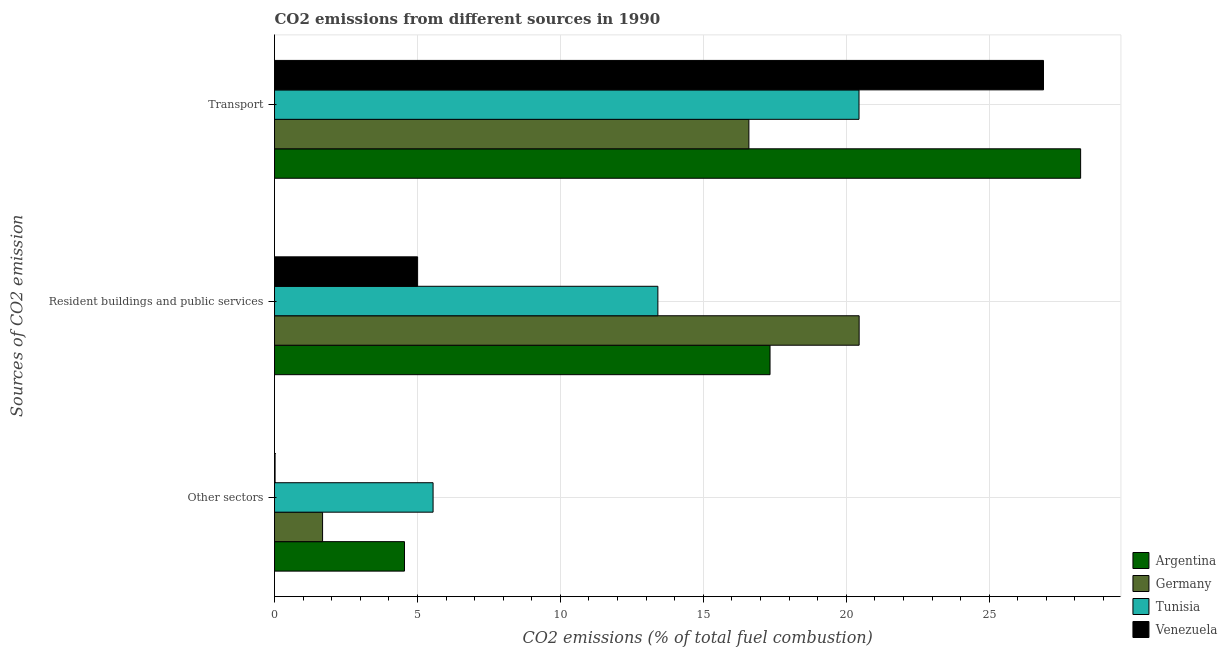How many different coloured bars are there?
Your answer should be very brief. 4. Are the number of bars on each tick of the Y-axis equal?
Make the answer very short. Yes. How many bars are there on the 2nd tick from the top?
Your answer should be compact. 4. How many bars are there on the 3rd tick from the bottom?
Provide a succinct answer. 4. What is the label of the 2nd group of bars from the top?
Give a very brief answer. Resident buildings and public services. What is the percentage of co2 emissions from other sectors in Germany?
Offer a very short reply. 1.68. Across all countries, what is the maximum percentage of co2 emissions from transport?
Keep it short and to the point. 28.2. Across all countries, what is the minimum percentage of co2 emissions from resident buildings and public services?
Your answer should be compact. 5.01. In which country was the percentage of co2 emissions from transport maximum?
Give a very brief answer. Argentina. In which country was the percentage of co2 emissions from other sectors minimum?
Offer a terse response. Venezuela. What is the total percentage of co2 emissions from transport in the graph?
Provide a short and direct response. 92.14. What is the difference between the percentage of co2 emissions from transport in Tunisia and that in Venezuela?
Make the answer very short. -6.45. What is the difference between the percentage of co2 emissions from other sectors in Venezuela and the percentage of co2 emissions from transport in Argentina?
Provide a succinct answer. -28.18. What is the average percentage of co2 emissions from resident buildings and public services per country?
Offer a very short reply. 14.05. What is the difference between the percentage of co2 emissions from transport and percentage of co2 emissions from other sectors in Venezuela?
Offer a very short reply. 26.88. In how many countries, is the percentage of co2 emissions from other sectors greater than 22 %?
Provide a succinct answer. 0. What is the ratio of the percentage of co2 emissions from resident buildings and public services in Germany to that in Venezuela?
Offer a terse response. 4.09. Is the percentage of co2 emissions from transport in Germany less than that in Argentina?
Offer a very short reply. Yes. Is the difference between the percentage of co2 emissions from transport in Tunisia and Germany greater than the difference between the percentage of co2 emissions from resident buildings and public services in Tunisia and Germany?
Keep it short and to the point. Yes. What is the difference between the highest and the second highest percentage of co2 emissions from other sectors?
Provide a succinct answer. 1. What is the difference between the highest and the lowest percentage of co2 emissions from other sectors?
Your answer should be compact. 5.53. In how many countries, is the percentage of co2 emissions from resident buildings and public services greater than the average percentage of co2 emissions from resident buildings and public services taken over all countries?
Make the answer very short. 2. What does the 3rd bar from the top in Transport represents?
Keep it short and to the point. Germany. What does the 3rd bar from the bottom in Other sectors represents?
Your answer should be compact. Tunisia. How are the legend labels stacked?
Offer a very short reply. Vertical. What is the title of the graph?
Offer a terse response. CO2 emissions from different sources in 1990. Does "Guam" appear as one of the legend labels in the graph?
Provide a succinct answer. No. What is the label or title of the X-axis?
Provide a short and direct response. CO2 emissions (% of total fuel combustion). What is the label or title of the Y-axis?
Offer a terse response. Sources of CO2 emission. What is the CO2 emissions (% of total fuel combustion) in Argentina in Other sectors?
Offer a very short reply. 4.55. What is the CO2 emissions (% of total fuel combustion) in Germany in Other sectors?
Provide a succinct answer. 1.68. What is the CO2 emissions (% of total fuel combustion) in Tunisia in Other sectors?
Offer a terse response. 5.55. What is the CO2 emissions (% of total fuel combustion) of Venezuela in Other sectors?
Give a very brief answer. 0.02. What is the CO2 emissions (% of total fuel combustion) of Argentina in Resident buildings and public services?
Make the answer very short. 17.33. What is the CO2 emissions (% of total fuel combustion) in Germany in Resident buildings and public services?
Ensure brevity in your answer.  20.45. What is the CO2 emissions (% of total fuel combustion) in Tunisia in Resident buildings and public services?
Offer a very short reply. 13.41. What is the CO2 emissions (% of total fuel combustion) of Venezuela in Resident buildings and public services?
Your response must be concise. 5.01. What is the CO2 emissions (% of total fuel combustion) in Argentina in Transport?
Offer a terse response. 28.2. What is the CO2 emissions (% of total fuel combustion) of Germany in Transport?
Your answer should be compact. 16.59. What is the CO2 emissions (% of total fuel combustion) in Tunisia in Transport?
Provide a succinct answer. 20.45. What is the CO2 emissions (% of total fuel combustion) of Venezuela in Transport?
Ensure brevity in your answer.  26.9. Across all Sources of CO2 emission, what is the maximum CO2 emissions (% of total fuel combustion) in Argentina?
Provide a short and direct response. 28.2. Across all Sources of CO2 emission, what is the maximum CO2 emissions (% of total fuel combustion) in Germany?
Provide a succinct answer. 20.45. Across all Sources of CO2 emission, what is the maximum CO2 emissions (% of total fuel combustion) in Tunisia?
Your answer should be compact. 20.45. Across all Sources of CO2 emission, what is the maximum CO2 emissions (% of total fuel combustion) in Venezuela?
Your answer should be compact. 26.9. Across all Sources of CO2 emission, what is the minimum CO2 emissions (% of total fuel combustion) of Argentina?
Keep it short and to the point. 4.55. Across all Sources of CO2 emission, what is the minimum CO2 emissions (% of total fuel combustion) of Germany?
Offer a terse response. 1.68. Across all Sources of CO2 emission, what is the minimum CO2 emissions (% of total fuel combustion) of Tunisia?
Make the answer very short. 5.55. Across all Sources of CO2 emission, what is the minimum CO2 emissions (% of total fuel combustion) of Venezuela?
Provide a short and direct response. 0.02. What is the total CO2 emissions (% of total fuel combustion) of Argentina in the graph?
Offer a terse response. 50.08. What is the total CO2 emissions (% of total fuel combustion) of Germany in the graph?
Keep it short and to the point. 38.73. What is the total CO2 emissions (% of total fuel combustion) in Tunisia in the graph?
Your answer should be very brief. 39.4. What is the total CO2 emissions (% of total fuel combustion) of Venezuela in the graph?
Your answer should be very brief. 31.93. What is the difference between the CO2 emissions (% of total fuel combustion) in Argentina in Other sectors and that in Resident buildings and public services?
Ensure brevity in your answer.  -12.79. What is the difference between the CO2 emissions (% of total fuel combustion) of Germany in Other sectors and that in Resident buildings and public services?
Give a very brief answer. -18.77. What is the difference between the CO2 emissions (% of total fuel combustion) of Tunisia in Other sectors and that in Resident buildings and public services?
Provide a succinct answer. -7.86. What is the difference between the CO2 emissions (% of total fuel combustion) in Venezuela in Other sectors and that in Resident buildings and public services?
Your response must be concise. -4.99. What is the difference between the CO2 emissions (% of total fuel combustion) of Argentina in Other sectors and that in Transport?
Make the answer very short. -23.65. What is the difference between the CO2 emissions (% of total fuel combustion) of Germany in Other sectors and that in Transport?
Your response must be concise. -14.91. What is the difference between the CO2 emissions (% of total fuel combustion) of Tunisia in Other sectors and that in Transport?
Your response must be concise. -14.9. What is the difference between the CO2 emissions (% of total fuel combustion) in Venezuela in Other sectors and that in Transport?
Keep it short and to the point. -26.88. What is the difference between the CO2 emissions (% of total fuel combustion) in Argentina in Resident buildings and public services and that in Transport?
Provide a succinct answer. -10.87. What is the difference between the CO2 emissions (% of total fuel combustion) of Germany in Resident buildings and public services and that in Transport?
Give a very brief answer. 3.86. What is the difference between the CO2 emissions (% of total fuel combustion) in Tunisia in Resident buildings and public services and that in Transport?
Offer a terse response. -7.04. What is the difference between the CO2 emissions (% of total fuel combustion) of Venezuela in Resident buildings and public services and that in Transport?
Offer a very short reply. -21.9. What is the difference between the CO2 emissions (% of total fuel combustion) of Argentina in Other sectors and the CO2 emissions (% of total fuel combustion) of Germany in Resident buildings and public services?
Offer a very short reply. -15.91. What is the difference between the CO2 emissions (% of total fuel combustion) in Argentina in Other sectors and the CO2 emissions (% of total fuel combustion) in Tunisia in Resident buildings and public services?
Your answer should be very brief. -8.86. What is the difference between the CO2 emissions (% of total fuel combustion) of Argentina in Other sectors and the CO2 emissions (% of total fuel combustion) of Venezuela in Resident buildings and public services?
Provide a short and direct response. -0.46. What is the difference between the CO2 emissions (% of total fuel combustion) in Germany in Other sectors and the CO2 emissions (% of total fuel combustion) in Tunisia in Resident buildings and public services?
Provide a succinct answer. -11.73. What is the difference between the CO2 emissions (% of total fuel combustion) in Germany in Other sectors and the CO2 emissions (% of total fuel combustion) in Venezuela in Resident buildings and public services?
Give a very brief answer. -3.32. What is the difference between the CO2 emissions (% of total fuel combustion) of Tunisia in Other sectors and the CO2 emissions (% of total fuel combustion) of Venezuela in Resident buildings and public services?
Your answer should be very brief. 0.54. What is the difference between the CO2 emissions (% of total fuel combustion) in Argentina in Other sectors and the CO2 emissions (% of total fuel combustion) in Germany in Transport?
Your answer should be very brief. -12.05. What is the difference between the CO2 emissions (% of total fuel combustion) in Argentina in Other sectors and the CO2 emissions (% of total fuel combustion) in Tunisia in Transport?
Provide a succinct answer. -15.9. What is the difference between the CO2 emissions (% of total fuel combustion) in Argentina in Other sectors and the CO2 emissions (% of total fuel combustion) in Venezuela in Transport?
Your answer should be compact. -22.35. What is the difference between the CO2 emissions (% of total fuel combustion) in Germany in Other sectors and the CO2 emissions (% of total fuel combustion) in Tunisia in Transport?
Give a very brief answer. -18.77. What is the difference between the CO2 emissions (% of total fuel combustion) in Germany in Other sectors and the CO2 emissions (% of total fuel combustion) in Venezuela in Transport?
Ensure brevity in your answer.  -25.22. What is the difference between the CO2 emissions (% of total fuel combustion) of Tunisia in Other sectors and the CO2 emissions (% of total fuel combustion) of Venezuela in Transport?
Ensure brevity in your answer.  -21.35. What is the difference between the CO2 emissions (% of total fuel combustion) of Argentina in Resident buildings and public services and the CO2 emissions (% of total fuel combustion) of Germany in Transport?
Your response must be concise. 0.74. What is the difference between the CO2 emissions (% of total fuel combustion) of Argentina in Resident buildings and public services and the CO2 emissions (% of total fuel combustion) of Tunisia in Transport?
Make the answer very short. -3.11. What is the difference between the CO2 emissions (% of total fuel combustion) of Argentina in Resident buildings and public services and the CO2 emissions (% of total fuel combustion) of Venezuela in Transport?
Your answer should be compact. -9.57. What is the difference between the CO2 emissions (% of total fuel combustion) of Germany in Resident buildings and public services and the CO2 emissions (% of total fuel combustion) of Tunisia in Transport?
Make the answer very short. 0. What is the difference between the CO2 emissions (% of total fuel combustion) in Germany in Resident buildings and public services and the CO2 emissions (% of total fuel combustion) in Venezuela in Transport?
Your answer should be very brief. -6.45. What is the difference between the CO2 emissions (% of total fuel combustion) in Tunisia in Resident buildings and public services and the CO2 emissions (% of total fuel combustion) in Venezuela in Transport?
Ensure brevity in your answer.  -13.49. What is the average CO2 emissions (% of total fuel combustion) in Argentina per Sources of CO2 emission?
Ensure brevity in your answer.  16.69. What is the average CO2 emissions (% of total fuel combustion) in Germany per Sources of CO2 emission?
Offer a terse response. 12.91. What is the average CO2 emissions (% of total fuel combustion) in Tunisia per Sources of CO2 emission?
Provide a succinct answer. 13.13. What is the average CO2 emissions (% of total fuel combustion) in Venezuela per Sources of CO2 emission?
Ensure brevity in your answer.  10.64. What is the difference between the CO2 emissions (% of total fuel combustion) of Argentina and CO2 emissions (% of total fuel combustion) of Germany in Other sectors?
Your answer should be compact. 2.87. What is the difference between the CO2 emissions (% of total fuel combustion) in Argentina and CO2 emissions (% of total fuel combustion) in Venezuela in Other sectors?
Provide a short and direct response. 4.53. What is the difference between the CO2 emissions (% of total fuel combustion) in Germany and CO2 emissions (% of total fuel combustion) in Tunisia in Other sectors?
Your answer should be compact. -3.87. What is the difference between the CO2 emissions (% of total fuel combustion) of Germany and CO2 emissions (% of total fuel combustion) of Venezuela in Other sectors?
Provide a succinct answer. 1.66. What is the difference between the CO2 emissions (% of total fuel combustion) in Tunisia and CO2 emissions (% of total fuel combustion) in Venezuela in Other sectors?
Your response must be concise. 5.53. What is the difference between the CO2 emissions (% of total fuel combustion) of Argentina and CO2 emissions (% of total fuel combustion) of Germany in Resident buildings and public services?
Your answer should be very brief. -3.12. What is the difference between the CO2 emissions (% of total fuel combustion) of Argentina and CO2 emissions (% of total fuel combustion) of Tunisia in Resident buildings and public services?
Your answer should be very brief. 3.92. What is the difference between the CO2 emissions (% of total fuel combustion) of Argentina and CO2 emissions (% of total fuel combustion) of Venezuela in Resident buildings and public services?
Keep it short and to the point. 12.33. What is the difference between the CO2 emissions (% of total fuel combustion) in Germany and CO2 emissions (% of total fuel combustion) in Tunisia in Resident buildings and public services?
Keep it short and to the point. 7.04. What is the difference between the CO2 emissions (% of total fuel combustion) in Germany and CO2 emissions (% of total fuel combustion) in Venezuela in Resident buildings and public services?
Your response must be concise. 15.45. What is the difference between the CO2 emissions (% of total fuel combustion) of Tunisia and CO2 emissions (% of total fuel combustion) of Venezuela in Resident buildings and public services?
Offer a very short reply. 8.41. What is the difference between the CO2 emissions (% of total fuel combustion) of Argentina and CO2 emissions (% of total fuel combustion) of Germany in Transport?
Provide a short and direct response. 11.61. What is the difference between the CO2 emissions (% of total fuel combustion) in Argentina and CO2 emissions (% of total fuel combustion) in Tunisia in Transport?
Make the answer very short. 7.75. What is the difference between the CO2 emissions (% of total fuel combustion) in Argentina and CO2 emissions (% of total fuel combustion) in Venezuela in Transport?
Your answer should be compact. 1.3. What is the difference between the CO2 emissions (% of total fuel combustion) in Germany and CO2 emissions (% of total fuel combustion) in Tunisia in Transport?
Offer a terse response. -3.85. What is the difference between the CO2 emissions (% of total fuel combustion) in Germany and CO2 emissions (% of total fuel combustion) in Venezuela in Transport?
Ensure brevity in your answer.  -10.31. What is the difference between the CO2 emissions (% of total fuel combustion) in Tunisia and CO2 emissions (% of total fuel combustion) in Venezuela in Transport?
Your answer should be very brief. -6.45. What is the ratio of the CO2 emissions (% of total fuel combustion) of Argentina in Other sectors to that in Resident buildings and public services?
Give a very brief answer. 0.26. What is the ratio of the CO2 emissions (% of total fuel combustion) in Germany in Other sectors to that in Resident buildings and public services?
Provide a short and direct response. 0.08. What is the ratio of the CO2 emissions (% of total fuel combustion) of Tunisia in Other sectors to that in Resident buildings and public services?
Ensure brevity in your answer.  0.41. What is the ratio of the CO2 emissions (% of total fuel combustion) of Venezuela in Other sectors to that in Resident buildings and public services?
Ensure brevity in your answer.  0. What is the ratio of the CO2 emissions (% of total fuel combustion) in Argentina in Other sectors to that in Transport?
Your answer should be compact. 0.16. What is the ratio of the CO2 emissions (% of total fuel combustion) in Germany in Other sectors to that in Transport?
Give a very brief answer. 0.1. What is the ratio of the CO2 emissions (% of total fuel combustion) in Tunisia in Other sectors to that in Transport?
Offer a very short reply. 0.27. What is the ratio of the CO2 emissions (% of total fuel combustion) of Venezuela in Other sectors to that in Transport?
Provide a succinct answer. 0. What is the ratio of the CO2 emissions (% of total fuel combustion) in Argentina in Resident buildings and public services to that in Transport?
Your response must be concise. 0.61. What is the ratio of the CO2 emissions (% of total fuel combustion) of Germany in Resident buildings and public services to that in Transport?
Provide a short and direct response. 1.23. What is the ratio of the CO2 emissions (% of total fuel combustion) of Tunisia in Resident buildings and public services to that in Transport?
Your answer should be very brief. 0.66. What is the ratio of the CO2 emissions (% of total fuel combustion) in Venezuela in Resident buildings and public services to that in Transport?
Your answer should be compact. 0.19. What is the difference between the highest and the second highest CO2 emissions (% of total fuel combustion) of Argentina?
Your response must be concise. 10.87. What is the difference between the highest and the second highest CO2 emissions (% of total fuel combustion) in Germany?
Make the answer very short. 3.86. What is the difference between the highest and the second highest CO2 emissions (% of total fuel combustion) of Tunisia?
Ensure brevity in your answer.  7.04. What is the difference between the highest and the second highest CO2 emissions (% of total fuel combustion) of Venezuela?
Your answer should be very brief. 21.9. What is the difference between the highest and the lowest CO2 emissions (% of total fuel combustion) of Argentina?
Give a very brief answer. 23.65. What is the difference between the highest and the lowest CO2 emissions (% of total fuel combustion) of Germany?
Your response must be concise. 18.77. What is the difference between the highest and the lowest CO2 emissions (% of total fuel combustion) of Tunisia?
Your answer should be compact. 14.9. What is the difference between the highest and the lowest CO2 emissions (% of total fuel combustion) of Venezuela?
Your answer should be compact. 26.88. 